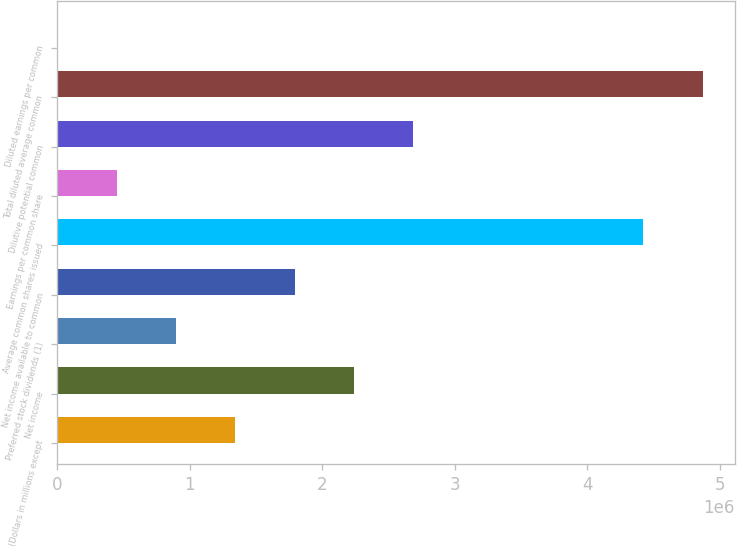Convert chart to OTSL. <chart><loc_0><loc_0><loc_500><loc_500><bar_chart><fcel>(Dollars in millions except<fcel>Net income<fcel>Preferred stock dividends (1)<fcel>Net income available to common<fcel>Average common shares issued<fcel>Earnings per common share<fcel>Dilutive potential common<fcel>Total diluted average common<fcel>Diluted earnings per common<nl><fcel>1.34408e+06<fcel>2.24013e+06<fcel>896053<fcel>1.7921e+06<fcel>4.42358e+06<fcel>448028<fcel>2.68815e+06<fcel>4.8716e+06<fcel>3.3<nl></chart> 